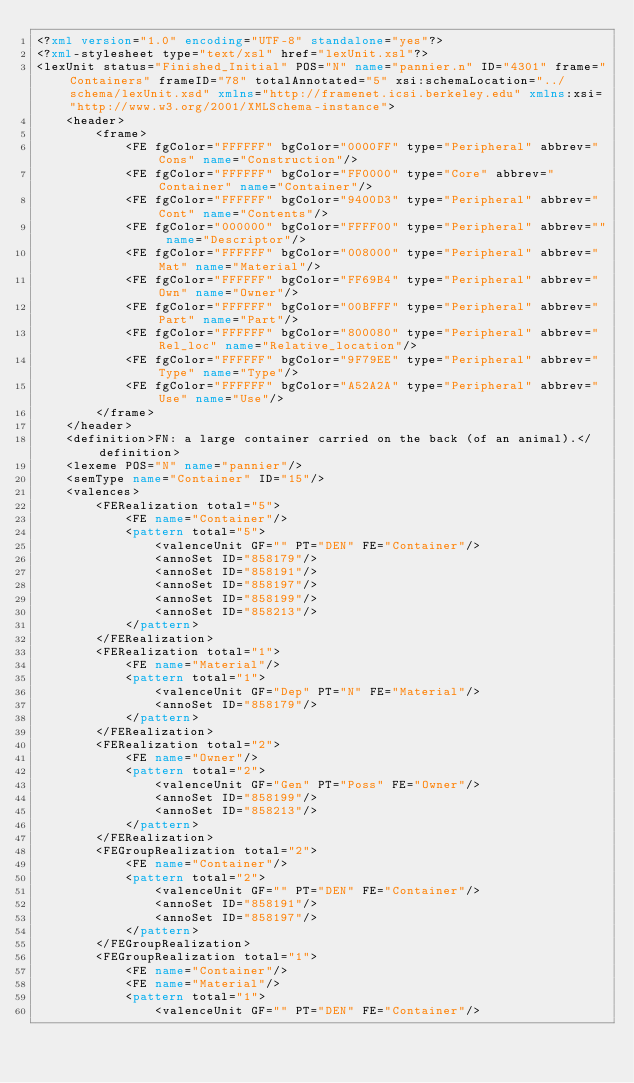<code> <loc_0><loc_0><loc_500><loc_500><_XML_><?xml version="1.0" encoding="UTF-8" standalone="yes"?>
<?xml-stylesheet type="text/xsl" href="lexUnit.xsl"?>
<lexUnit status="Finished_Initial" POS="N" name="pannier.n" ID="4301" frame="Containers" frameID="78" totalAnnotated="5" xsi:schemaLocation="../schema/lexUnit.xsd" xmlns="http://framenet.icsi.berkeley.edu" xmlns:xsi="http://www.w3.org/2001/XMLSchema-instance">
    <header>
        <frame>
            <FE fgColor="FFFFFF" bgColor="0000FF" type="Peripheral" abbrev="Cons" name="Construction"/>
            <FE fgColor="FFFFFF" bgColor="FF0000" type="Core" abbrev="Container" name="Container"/>
            <FE fgColor="FFFFFF" bgColor="9400D3" type="Peripheral" abbrev="Cont" name="Contents"/>
            <FE fgColor="000000" bgColor="FFFF00" type="Peripheral" abbrev="" name="Descriptor"/>
            <FE fgColor="FFFFFF" bgColor="008000" type="Peripheral" abbrev="Mat" name="Material"/>
            <FE fgColor="FFFFFF" bgColor="FF69B4" type="Peripheral" abbrev="Own" name="Owner"/>
            <FE fgColor="FFFFFF" bgColor="00BFFF" type="Peripheral" abbrev="Part" name="Part"/>
            <FE fgColor="FFFFFF" bgColor="800080" type="Peripheral" abbrev="Rel_loc" name="Relative_location"/>
            <FE fgColor="FFFFFF" bgColor="9F79EE" type="Peripheral" abbrev="Type" name="Type"/>
            <FE fgColor="FFFFFF" bgColor="A52A2A" type="Peripheral" abbrev="Use" name="Use"/>
        </frame>
    </header>
    <definition>FN: a large container carried on the back (of an animal).</definition>
    <lexeme POS="N" name="pannier"/>
    <semType name="Container" ID="15"/>
    <valences>
        <FERealization total="5">
            <FE name="Container"/>
            <pattern total="5">
                <valenceUnit GF="" PT="DEN" FE="Container"/>
                <annoSet ID="858179"/>
                <annoSet ID="858191"/>
                <annoSet ID="858197"/>
                <annoSet ID="858199"/>
                <annoSet ID="858213"/>
            </pattern>
        </FERealization>
        <FERealization total="1">
            <FE name="Material"/>
            <pattern total="1">
                <valenceUnit GF="Dep" PT="N" FE="Material"/>
                <annoSet ID="858179"/>
            </pattern>
        </FERealization>
        <FERealization total="2">
            <FE name="Owner"/>
            <pattern total="2">
                <valenceUnit GF="Gen" PT="Poss" FE="Owner"/>
                <annoSet ID="858199"/>
                <annoSet ID="858213"/>
            </pattern>
        </FERealization>
        <FEGroupRealization total="2">
            <FE name="Container"/>
            <pattern total="2">
                <valenceUnit GF="" PT="DEN" FE="Container"/>
                <annoSet ID="858191"/>
                <annoSet ID="858197"/>
            </pattern>
        </FEGroupRealization>
        <FEGroupRealization total="1">
            <FE name="Container"/>
            <FE name="Material"/>
            <pattern total="1">
                <valenceUnit GF="" PT="DEN" FE="Container"/></code> 